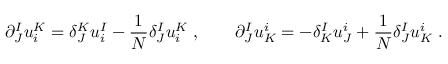Convert formula to latex. <formula><loc_0><loc_0><loc_500><loc_500>\partial _ { J } ^ { I } u _ { i } ^ { K } = \delta _ { J } ^ { K } u _ { i } ^ { I } - { \frac { 1 } { N } } \delta _ { J } ^ { I } u _ { i } ^ { K } \, , \quad \partial _ { J } ^ { I } u _ { K } ^ { i } = - \delta _ { K } ^ { I } u _ { J } ^ { i } + { \frac { 1 } { N } } \delta _ { J } ^ { I } u _ { K } ^ { i } \, .</formula> 